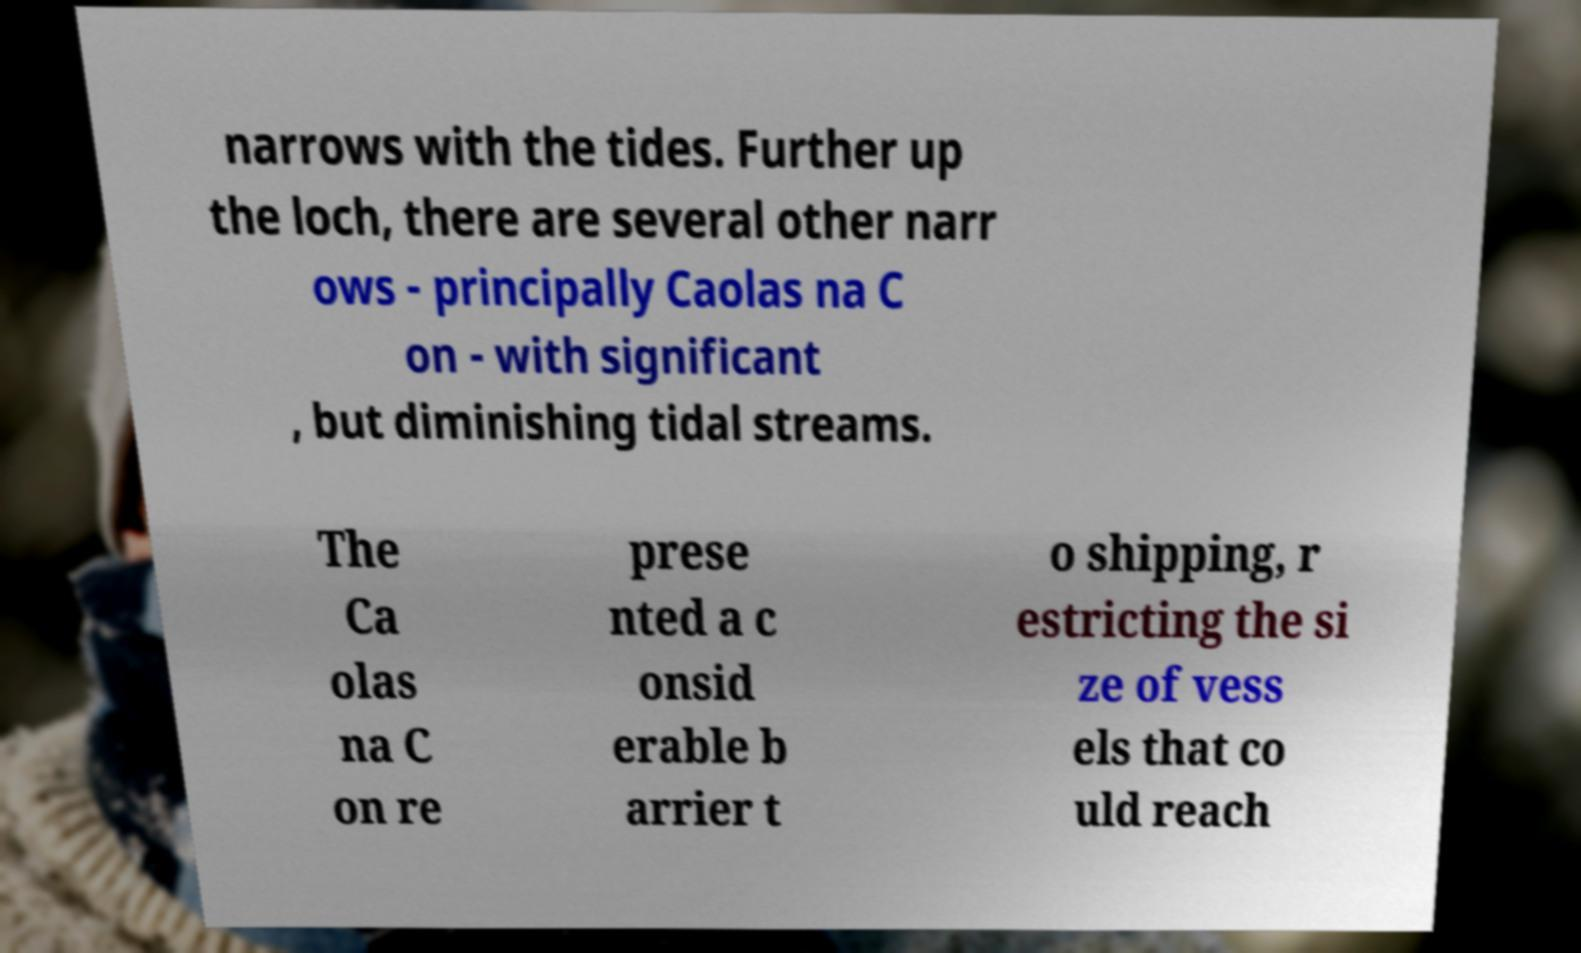Could you assist in decoding the text presented in this image and type it out clearly? narrows with the tides. Further up the loch, there are several other narr ows - principally Caolas na C on - with significant , but diminishing tidal streams. The Ca olas na C on re prese nted a c onsid erable b arrier t o shipping, r estricting the si ze of vess els that co uld reach 